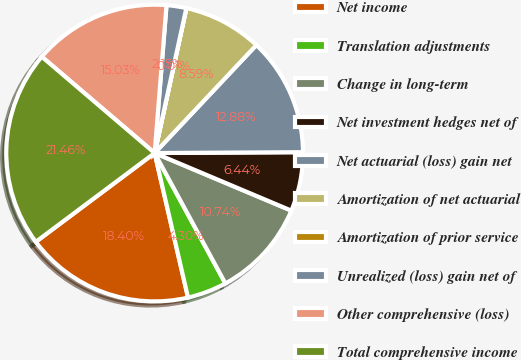Convert chart. <chart><loc_0><loc_0><loc_500><loc_500><pie_chart><fcel>Net income<fcel>Translation adjustments<fcel>Change in long-term<fcel>Net investment hedges net of<fcel>Net actuarial (loss) gain net<fcel>Amortization of net actuarial<fcel>Amortization of prior service<fcel>Unrealized (loss) gain net of<fcel>Other comprehensive (loss)<fcel>Total comprehensive income<nl><fcel>18.4%<fcel>4.3%<fcel>10.74%<fcel>6.44%<fcel>12.88%<fcel>8.59%<fcel>0.01%<fcel>2.15%<fcel>15.03%<fcel>21.46%<nl></chart> 